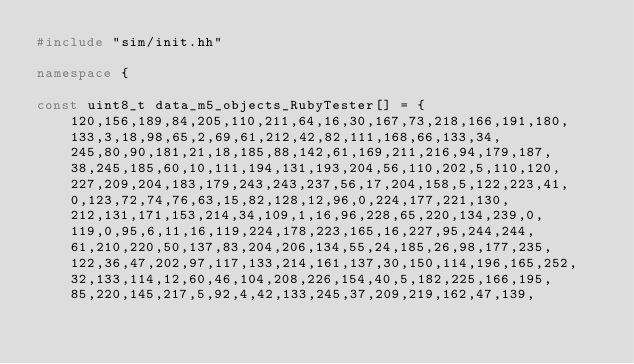<code> <loc_0><loc_0><loc_500><loc_500><_C++_>#include "sim/init.hh"

namespace {

const uint8_t data_m5_objects_RubyTester[] = {
    120,156,189,84,205,110,211,64,16,30,167,73,218,166,191,180,
    133,3,18,98,65,2,69,61,212,42,82,111,168,66,133,34,
    245,80,90,181,21,18,185,88,142,61,169,211,216,94,179,187,
    38,245,185,60,10,111,194,131,193,204,56,110,202,5,110,120,
    227,209,204,183,179,243,243,237,56,17,204,158,5,122,223,41,
    0,123,72,74,76,63,15,82,128,12,96,0,224,177,221,130,
    212,131,171,153,214,34,109,1,16,96,228,65,220,134,239,0,
    119,0,95,6,11,16,119,224,178,223,165,16,227,95,244,244,
    61,210,220,50,137,83,204,206,134,55,24,185,26,98,177,235,
    122,36,47,202,97,117,133,214,161,137,30,150,114,196,165,252,
    32,133,114,12,60,46,104,208,226,154,40,5,182,225,166,195,
    85,220,145,217,5,92,4,42,133,245,37,209,219,162,47,139,</code> 